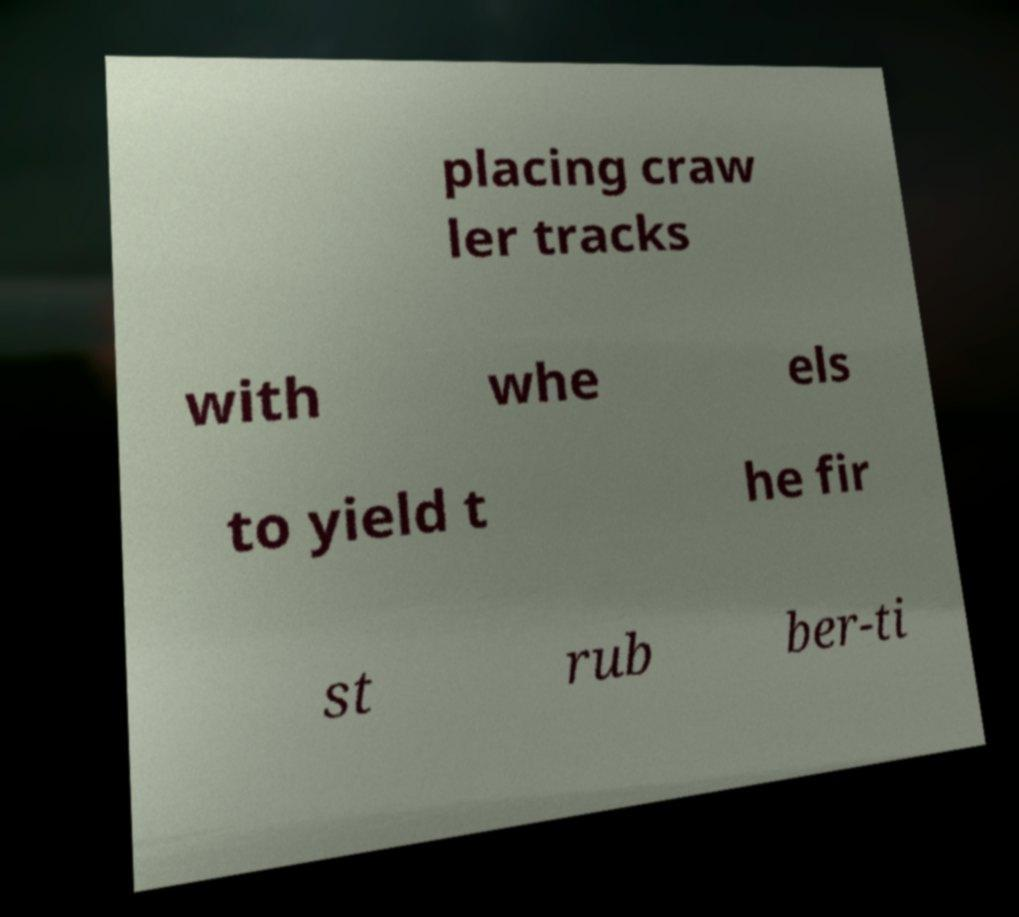Please identify and transcribe the text found in this image. placing craw ler tracks with whe els to yield t he fir st rub ber-ti 